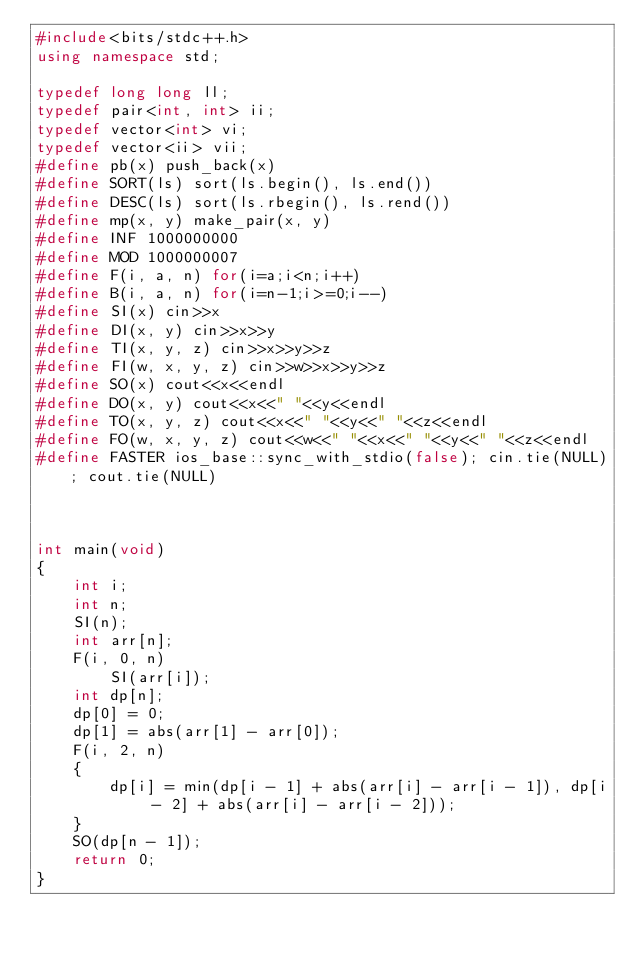<code> <loc_0><loc_0><loc_500><loc_500><_C++_>#include<bits/stdc++.h>
using namespace std;

typedef long long ll;
typedef pair<int, int> ii;
typedef vector<int> vi;
typedef vector<ii> vii;
#define pb(x) push_back(x)
#define SORT(ls) sort(ls.begin(), ls.end())
#define DESC(ls) sort(ls.rbegin(), ls.rend()) 
#define mp(x, y) make_pair(x, y)
#define INF 1000000000
#define MOD 1000000007
#define F(i, a, n) for(i=a;i<n;i++)
#define B(i, a, n) for(i=n-1;i>=0;i--)
#define SI(x) cin>>x
#define DI(x, y) cin>>x>>y
#define TI(x, y, z) cin>>x>>y>>z
#define FI(w, x, y, z) cin>>w>>x>>y>>z
#define SO(x) cout<<x<<endl
#define DO(x, y) cout<<x<<" "<<y<<endl
#define TO(x, y, z) cout<<x<<" "<<y<<" "<<z<<endl
#define FO(w, x, y, z) cout<<w<<" "<<x<<" "<<y<<" "<<z<<endl
#define FASTER ios_base::sync_with_stdio(false); cin.tie(NULL); cout.tie(NULL)



int main(void)
{
    int i;
    int n;
    SI(n);
    int arr[n];
    F(i, 0, n)
        SI(arr[i]);
    int dp[n];
    dp[0] = 0;
    dp[1] = abs(arr[1] - arr[0]);
    F(i, 2, n)
    {
        dp[i] = min(dp[i - 1] + abs(arr[i] - arr[i - 1]), dp[i - 2] + abs(arr[i] - arr[i - 2]));
    }
    SO(dp[n - 1]);
    return 0;
}</code> 